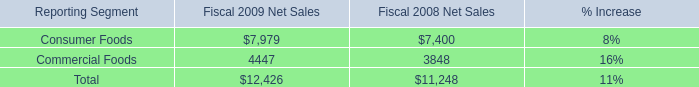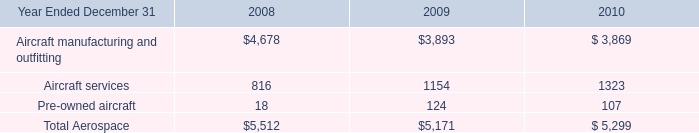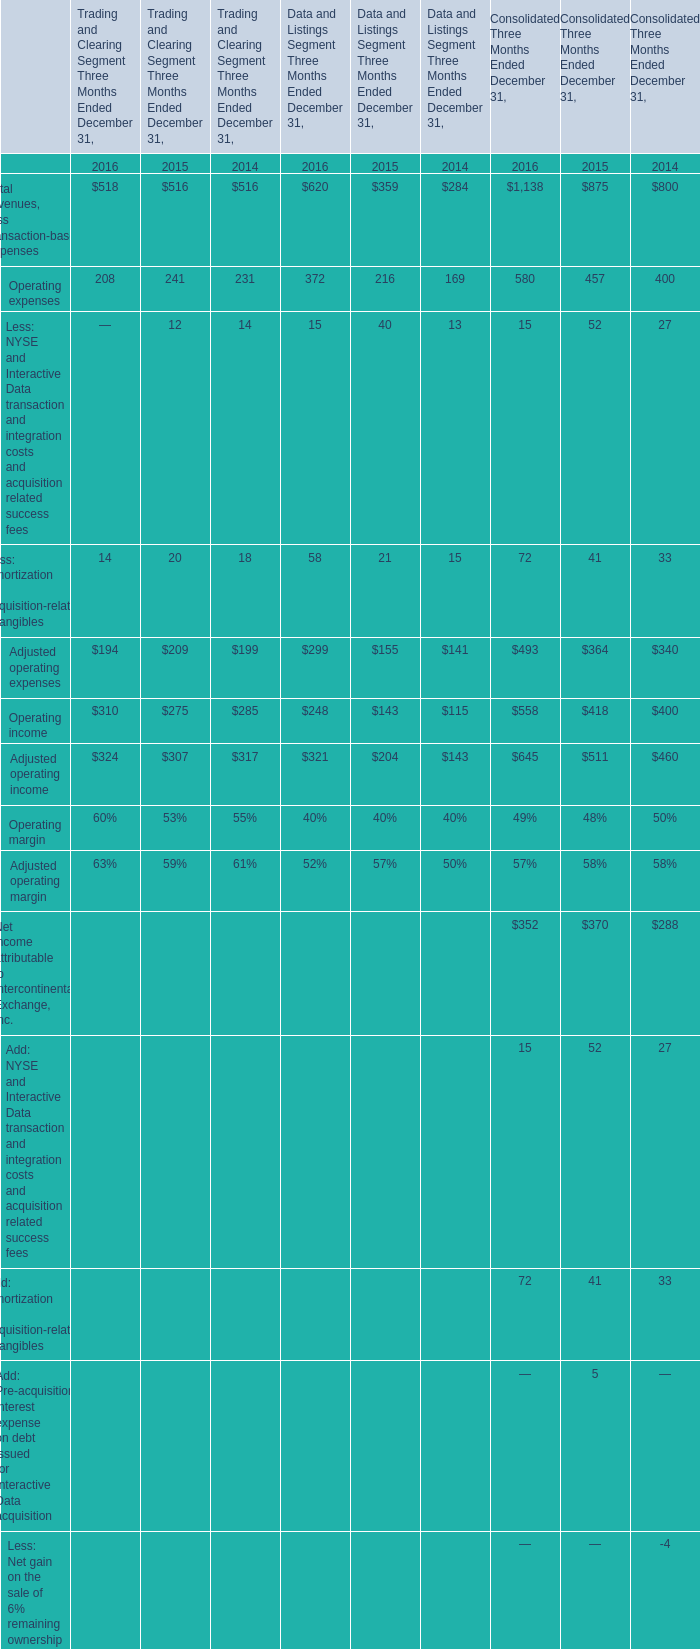When does Total revenues, less transaction-based expenses for Data and Listings Segment Three Months Ended December 31 reach the largest value? 
Answer: 2016. 